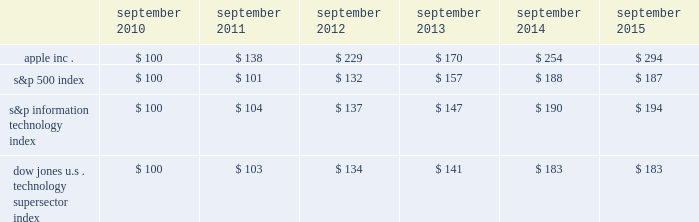Table of contents company stock performance the following graph shows a comparison of cumulative total shareholder return , calculated on a dividend reinvested basis , for the company , the s&p 500 index , the s&p information technology index and the dow jones u.s .
Technology supersector index for the five years ended september 26 , 2015 .
The graph assumes $ 100 was invested in each of the company 2019s common stock , the s&p 500 index , the s&p information technology index and the dow jones u.s .
Technology supersector index as of the market close on september 24 , 2010 .
Note that historic stock price performance is not necessarily indicative of future stock price performance .
* $ 100 invested on 9/25/10 in stock or index , including reinvestment of dividends .
Data points are the last day of each fiscal year for the company 2019scommon stock and september 30th for indexes .
Copyright a9 2015 s&p , a division of mcgraw hill financial .
All rights reserved .
Copyright a9 2015 dow jones & co .
All rights reserved .
September september september september september september .
Apple inc .
| 2015 form 10-k | 21 .
What was the percentage cumulative total shareholder return for the five years ended 2015? 
Computations: ((294 - 100) / 100)
Answer: 1.94. 